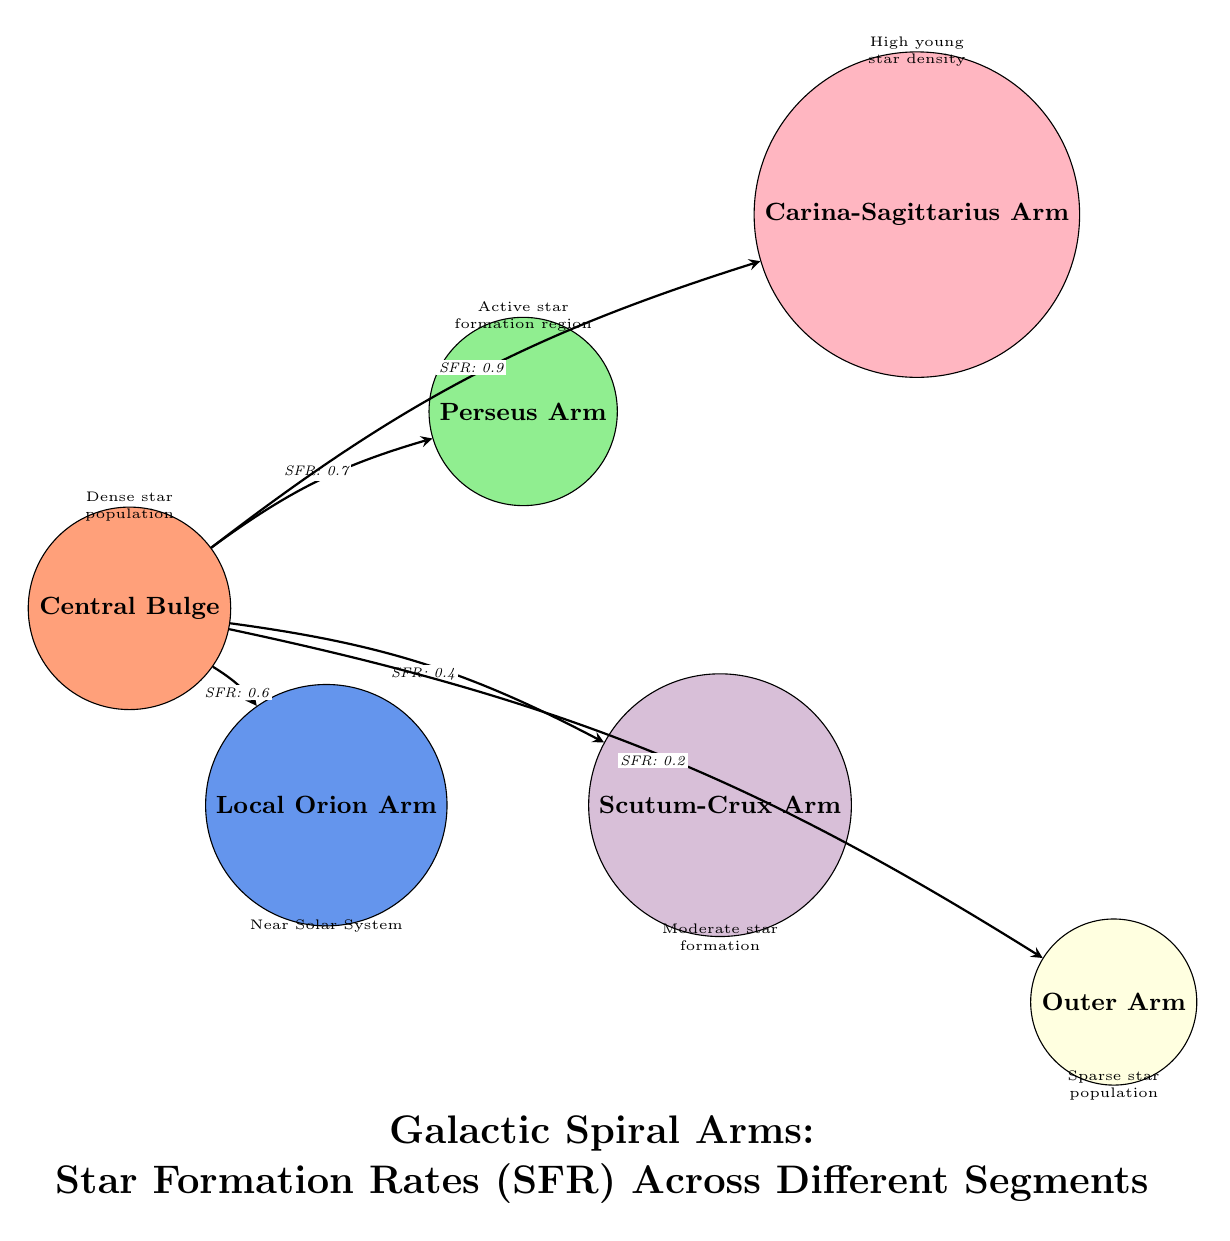What is the star formation rate in the Carina-Sagittarius Arm? The diagram indicates that the star formation rate (SFR) in the Carina-Sagittarius Arm is labeled as "0.9".
Answer: 0.9 What is the color representing the Local Orion Arm? The Local Orion Arm is filled with a soft blue color, which is indicated in the diagram's legend for its node.
Answer: Soft blue Which arm has the highest star formation rate? By comparing the SFR values indicated on the edges, the Carina-Sagittarius Arm has the highest value of "0.9".
Answer: Carina-Sagittarius Arm How many arms are visually represented in the diagram? The diagram shows a total of five distinct arms connected to the central bulge, represented as nodes in the diagram.
Answer: Five What is the star formation rate in the Outer Arm? The diagram specifies that the SFR in the Outer Arm is "0.2", which is labeled on the edge connecting it to the central bulge.
Answer: 0.2 Which arm is closest to the Central Bulge? The Local Orion Arm is the closest arm to the Central Bulge, as indicated by the shortest distance and direct connection in the diagram.
Answer: Local Orion Arm Which arm has a star formation rate labeled as "0.4"? The Scutum-Crux Arm has the SFR labeled as "0.4", as shown by the edge connecting it to the Central Bulge.
Answer: Scutum-Crux Arm Which region is described as having a "sparse star population"? The Outer Arm is described in the diagram as having a "sparse star population", providing a qualitative assessment of that area.
Answer: Outer Arm 